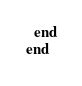Convert code to text. <code><loc_0><loc_0><loc_500><loc_500><_Ruby_>  end
end
</code> 